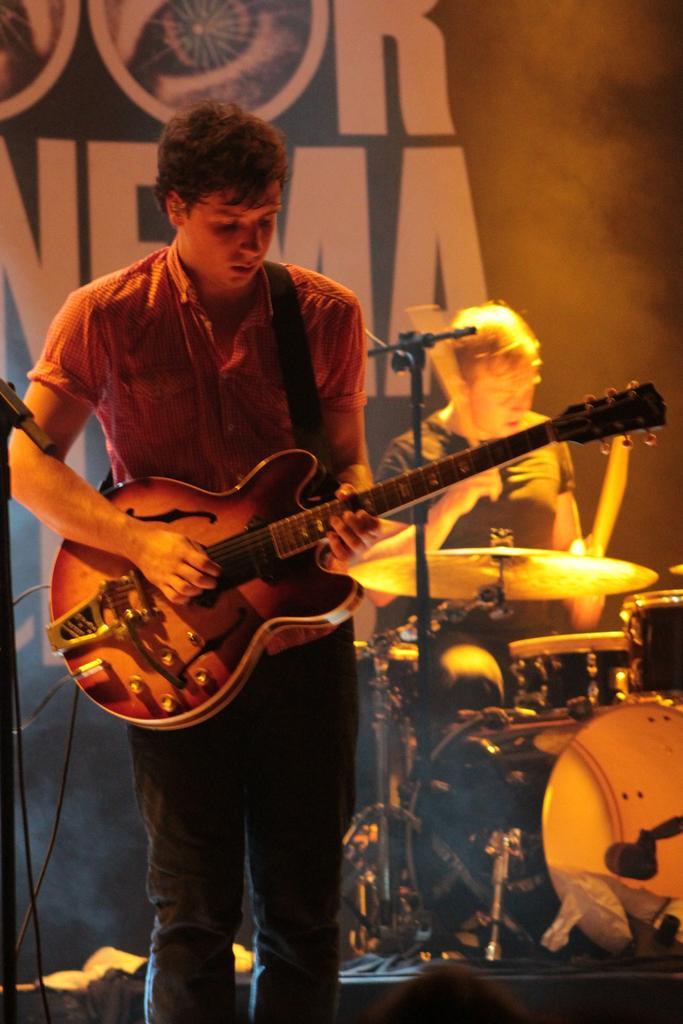Describe this image in one or two sentences. This man wore shirt and playing guitar. Far this person is holding sticks and playing these musical instruments. 